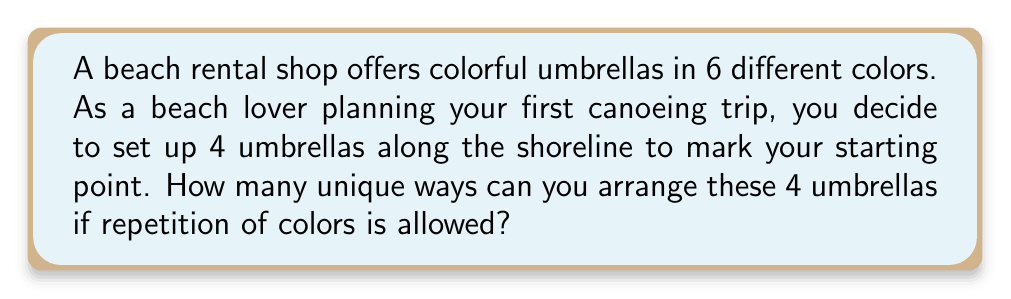Teach me how to tackle this problem. Let's approach this step-by-step:

1) This is a problem of arrangements with repetition allowed. We can use the multiplication principle to solve it.

2) For each position, we have 6 color choices, and this is true for all 4 positions.

3) The number of ways to fill each position can be represented as:
   $$ 6 \times 6 \times 6 \times 6 $$

4) This can be written more concisely as:
   $$ 6^4 $$

5) Calculating this:
   $$ 6^4 = 6 \times 6 \times 6 \times 6 = 1296 $$

Therefore, there are 1296 unique ways to arrange 4 umbrellas chosen from 6 colors, with repetition allowed.
Answer: $1296$ 